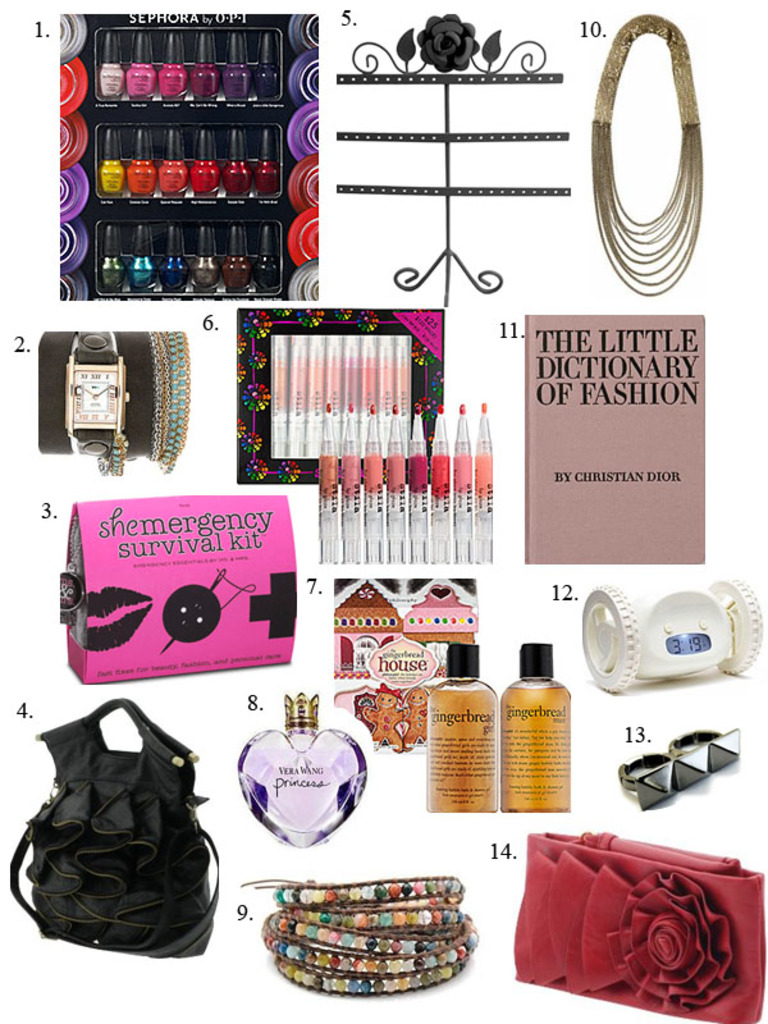What are the uses of the 'shemergency survival kit' shown in the image? The 'shemergency survival kit' likely includes items essential for fashion or beauty-related emergencies, such as sewing essentials, beauty tools, and quick-fix adhesive products, perfect for on-the-go or travel situations. 